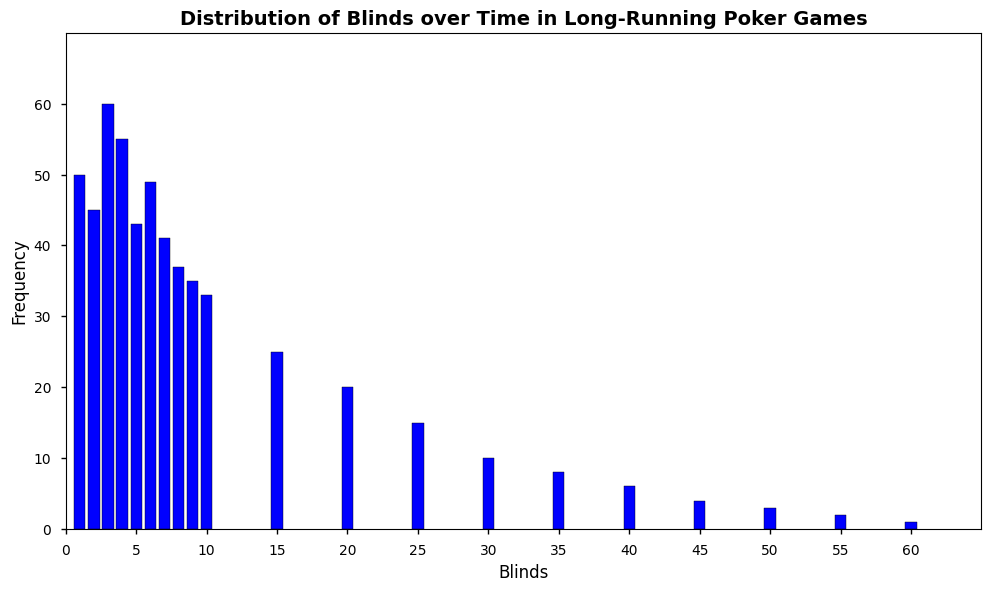What's the highest frequency blind level? The highest frequency blind level can be identified by finding the tallest bar in the histogram. The tallest bar is at blind level 3, with a frequency of 60.
Answer: 3 Which blind level had the lowest frequency? The lowest frequency blind level is found by identifying the shortest bar in the histogram. The bar at blind level 60 is the shortest, with a frequency of 1.
Answer: 60 What is the total combined frequency for blinds under 10? Sum the frequencies for blind levels 1 through 9: 50 + 45 + 60 + 55 + 43 + 49 + 41 + 37 + 35. The total sum is 415.
Answer: 415 How many blind levels have a frequency greater than 30? Count the number of bars with a height representing a frequency greater than 30. The blind levels 1, 2, 3, 4, 5, 6, 7, and 8 fit this criterion, for a total of 8 blind levels.
Answer: 8 Is the frequency of the blind level 20 higher or lower than that of the blind level 10? Compare the heights of the bars at blind levels 20 and 10. The frequency at blind level 20 is 20, and at blind level 10, it is 33. Therefore, the frequency at blind level 20 is lower.
Answer: Lower What is the average frequency of blind levels from 1 to 5? Calculate the average by summing the frequencies of blind levels 1 to 5 and dividing by the number of levels: (50 + 45 + 60 + 55 + 43)/5 = 253/5 = 50.6.
Answer: 50.6 Between which blind levels is the most significant drop in frequency observed? Identify the pair of adjacent bars with the largest difference in height. The most prominent drop is between blind levels 10 (frequency 33) and 15 (frequency 25), a drop of 8.
Answer: 10 and 15 What is the range of the blinds displayed in the histogram? The range is calculated by subtracting the smallest blind level from the largest. The smallest is 1, and the largest is 60. Therefore, the range is 60 - 1 = 59.
Answer: 59 Which blind levels have a frequency between 10 and 20? Identify the bars that have heights representing frequencies within this range. The blind levels 15, 20, 25, 30, and 35 have frequencies of 25, 20, 15, 10, and 8 respectively, with most within the 10 to 20 range.
Answer: 15, 20, 25, 30, 35 